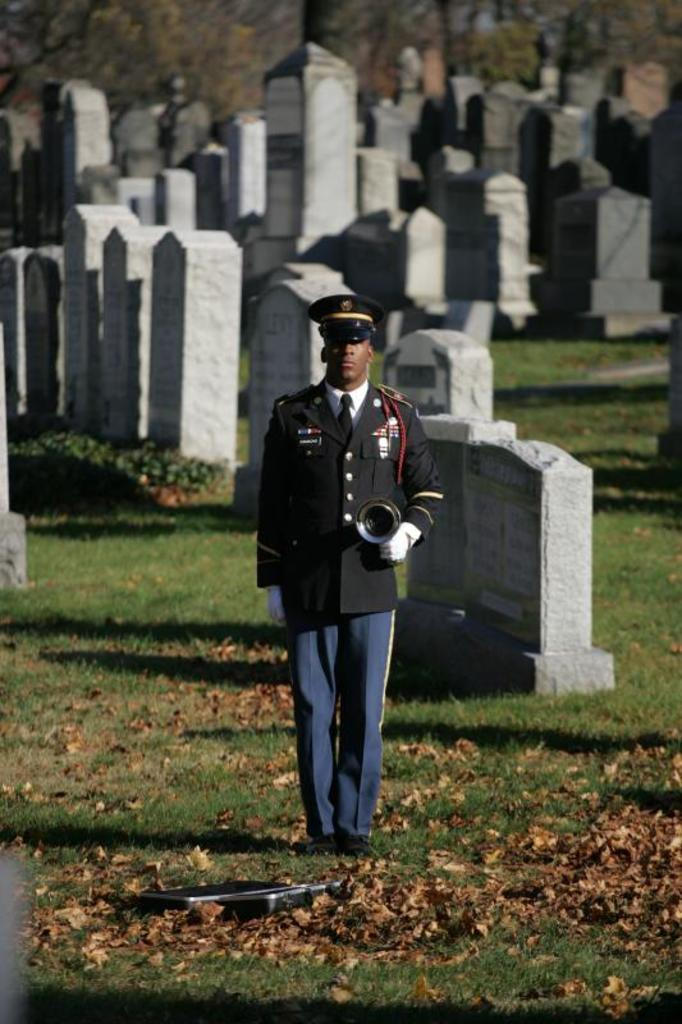What type of vegetation can be seen in the image? There are trees in the image. What type of structures are present in the image? There are gravestones in the image. Can you describe the person in the image? There is a person standing on the ground in the image. What is the ground covered with in the image? Shredded leaves are present in the image. What type of airplane can be seen flying over the trees in the image? There is no airplane present in the image; it only features trees, gravestones, a person, and shredded leaves. Can you hear the person in the image laughing? The image is silent, and there is no indication of laughter or any sound. 